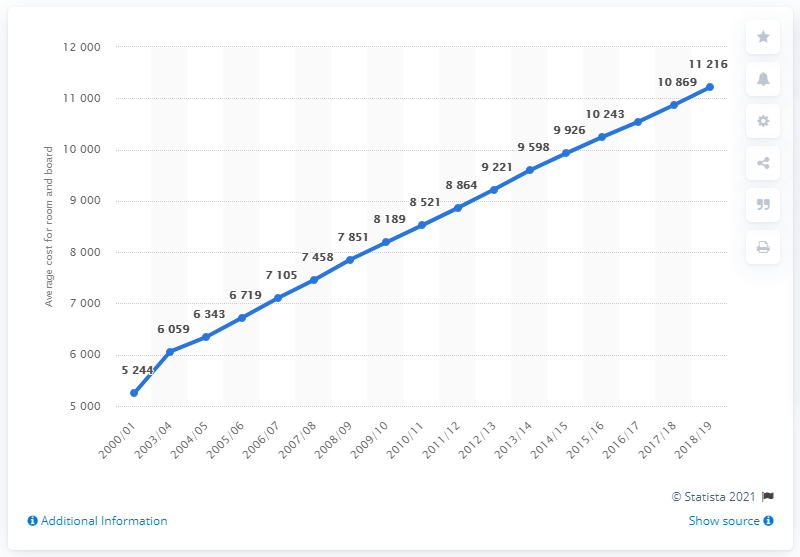Indicate a few pertinent items in this graphic. In the year 2018/19, the cost was the highest on record. The median is 8,521. 